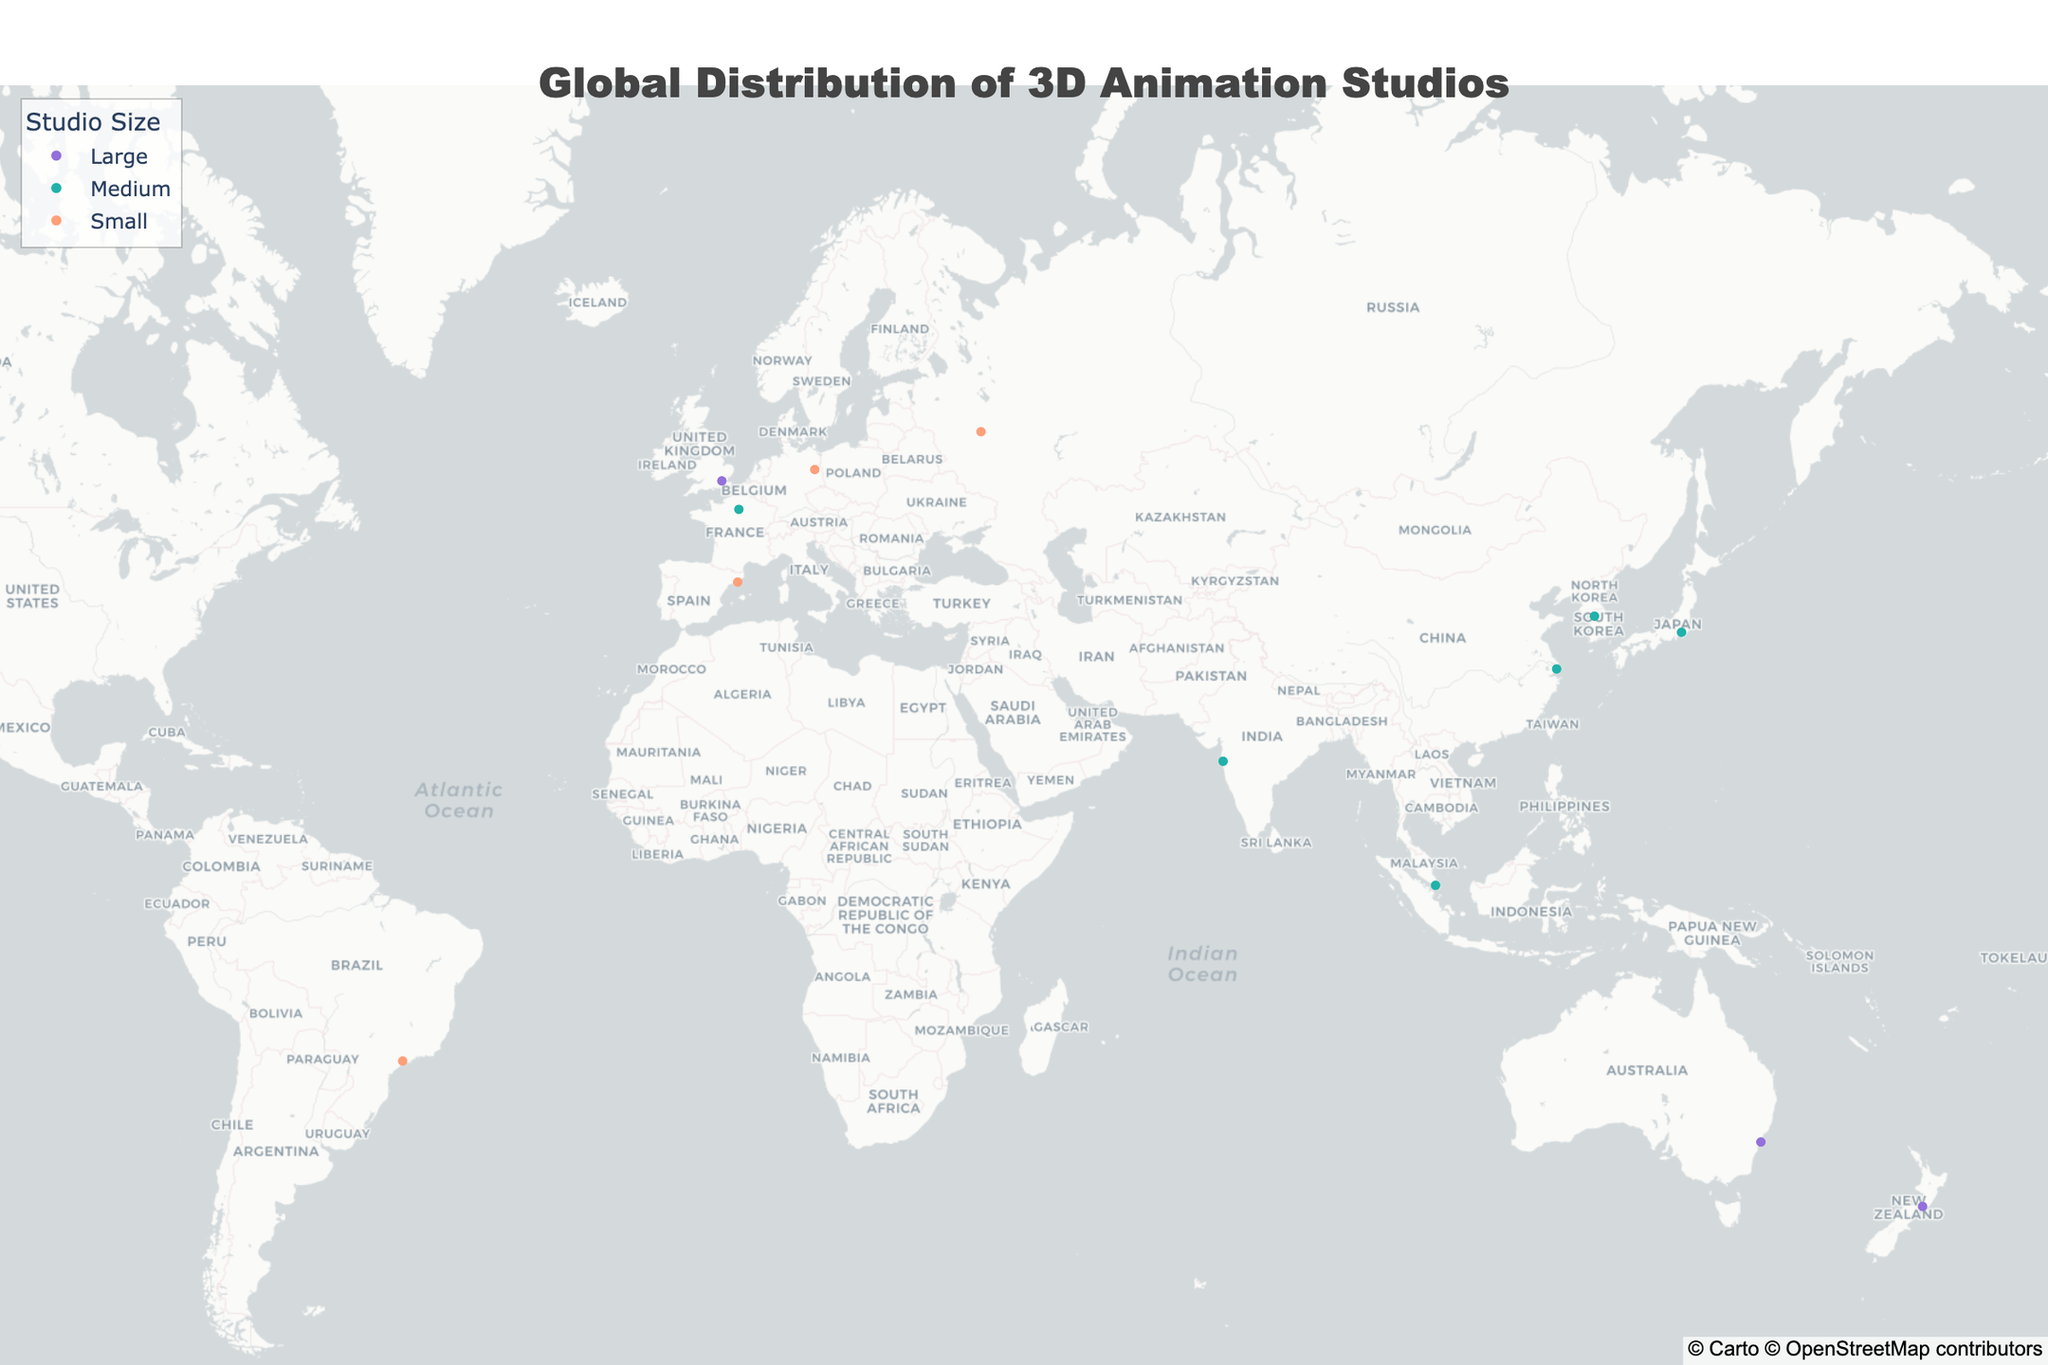Which two cities have the largest number of large studios? Los Angeles and Wellington each have one large studio marked on the map, whereas other cities either have medium or small studios and fewer counts or none.
Answer: Los Angeles and Wellington How many studios specialize in feature films? The studios and their specialties are denoted on the annotations of the map. Feature films are noted for 5 studios (Pixar Animation Studios, Illumination Mac Guff, Original Force, Animal Logic, and Wizart Animation).
Answer: 5 What is the studio located at the southernmost point on the map? The latitude and longitude values on the map show the southernmost point is -41.2865 (Wellington), which corresponds to Weta Digital.
Answer: Weta Digital Compare the number of VFX-specializing studios in North America versus Europe. VFX studios in North America: 2 (Framestore in London, Industrial Light & Magic in Vancouver). VFX studios in Europe: 2 (Framestore in London, Rise FX in Berlin).
Answer: Equal Which studio is situated closest to the equator? The equator is at 0 degrees latitude, the closest studio is in Singapore with a latitude of 1.3521 One Animation in Singapore.
Answer: One Animation Which countries have animation studios specializing in TV series? Identify countries based on the annotations. The countries with TV series specialties are India (Mumbai), Spain (Barcelona), and Singapore (Singapore).
Answer: India, Spain, Singapore What are the largest studios on different continents? North America: Pixar Animation Studios (Los Angeles), South America: None, Europe: Framestore (London), Asia: None, Oceania: Weta Digital (Wellington), Africa: None.
Answer: North America: Pixar Animation Studios, Oceania: Weta Digital Is there any country with more than one studio? The map data marks one studio per country, showing distribution across various countries with no repeats.
Answer: No 